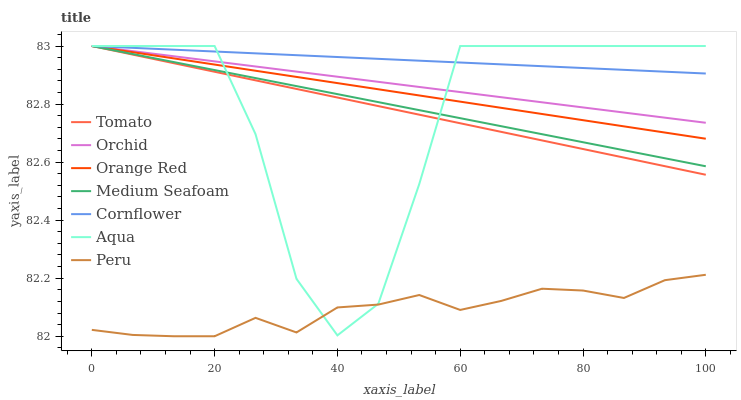Does Peru have the minimum area under the curve?
Answer yes or no. Yes. Does Cornflower have the maximum area under the curve?
Answer yes or no. Yes. Does Aqua have the minimum area under the curve?
Answer yes or no. No. Does Aqua have the maximum area under the curve?
Answer yes or no. No. Is Orange Red the smoothest?
Answer yes or no. Yes. Is Aqua the roughest?
Answer yes or no. Yes. Is Cornflower the smoothest?
Answer yes or no. No. Is Cornflower the roughest?
Answer yes or no. No. Does Aqua have the lowest value?
Answer yes or no. No. Does Orchid have the highest value?
Answer yes or no. Yes. Does Peru have the highest value?
Answer yes or no. No. Is Peru less than Orange Red?
Answer yes or no. Yes. Is Medium Seafoam greater than Peru?
Answer yes or no. Yes. Does Peru intersect Orange Red?
Answer yes or no. No. 